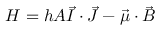<formula> <loc_0><loc_0><loc_500><loc_500>H = h A { \vec { I } } \cdot { \vec { J } } - { \vec { \mu } } \cdot { \vec { B } }</formula> 